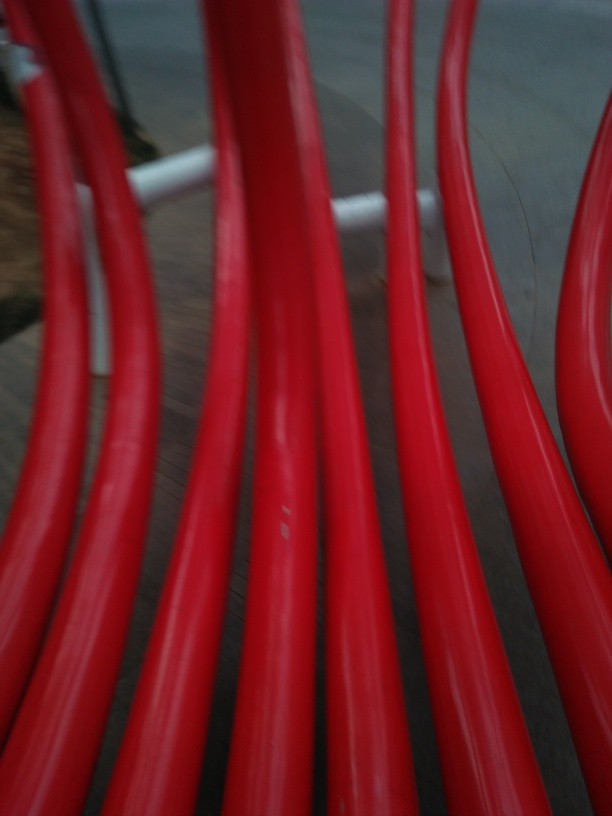What might be the significance of the blurred red lines in this image? While the specific significance of the blurred red lines isn't clear without additional context, they could represent movement or speed. Their dynamic curvature and the way they dominate the image may evoke a sense of fluidity or the fast pace of life. In abstract photography, such interpretations are subjective and often guided by the viewer's personal experiences and emotions. 